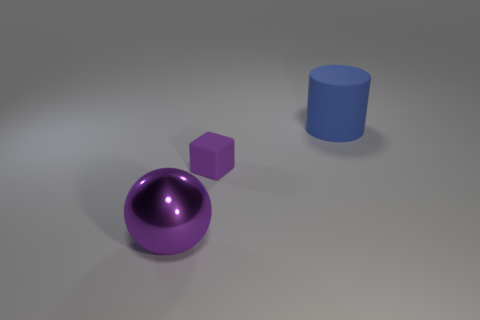Add 1 metallic objects. How many objects exist? 4 Subtract all cylinders. How many objects are left? 2 Subtract all matte blocks. Subtract all tiny matte objects. How many objects are left? 1 Add 2 big cylinders. How many big cylinders are left? 3 Add 2 big red balls. How many big red balls exist? 2 Subtract 1 purple spheres. How many objects are left? 2 